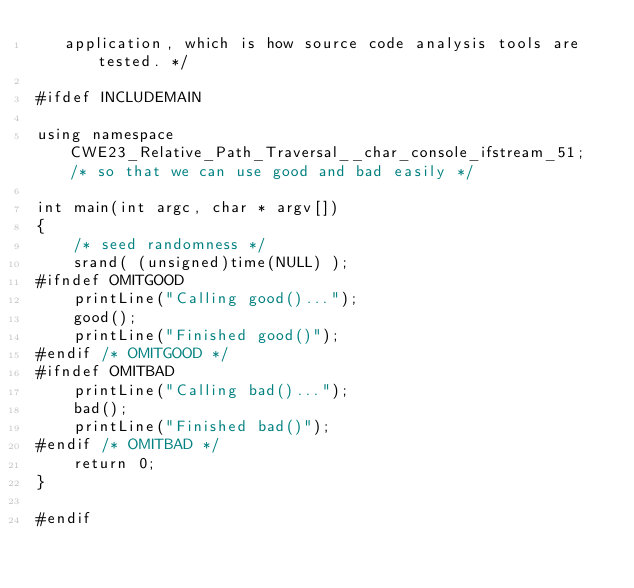<code> <loc_0><loc_0><loc_500><loc_500><_C++_>   application, which is how source code analysis tools are tested. */

#ifdef INCLUDEMAIN

using namespace CWE23_Relative_Path_Traversal__char_console_ifstream_51; /* so that we can use good and bad easily */

int main(int argc, char * argv[])
{
    /* seed randomness */
    srand( (unsigned)time(NULL) );
#ifndef OMITGOOD
    printLine("Calling good()...");
    good();
    printLine("Finished good()");
#endif /* OMITGOOD */
#ifndef OMITBAD
    printLine("Calling bad()...");
    bad();
    printLine("Finished bad()");
#endif /* OMITBAD */
    return 0;
}

#endif
</code> 